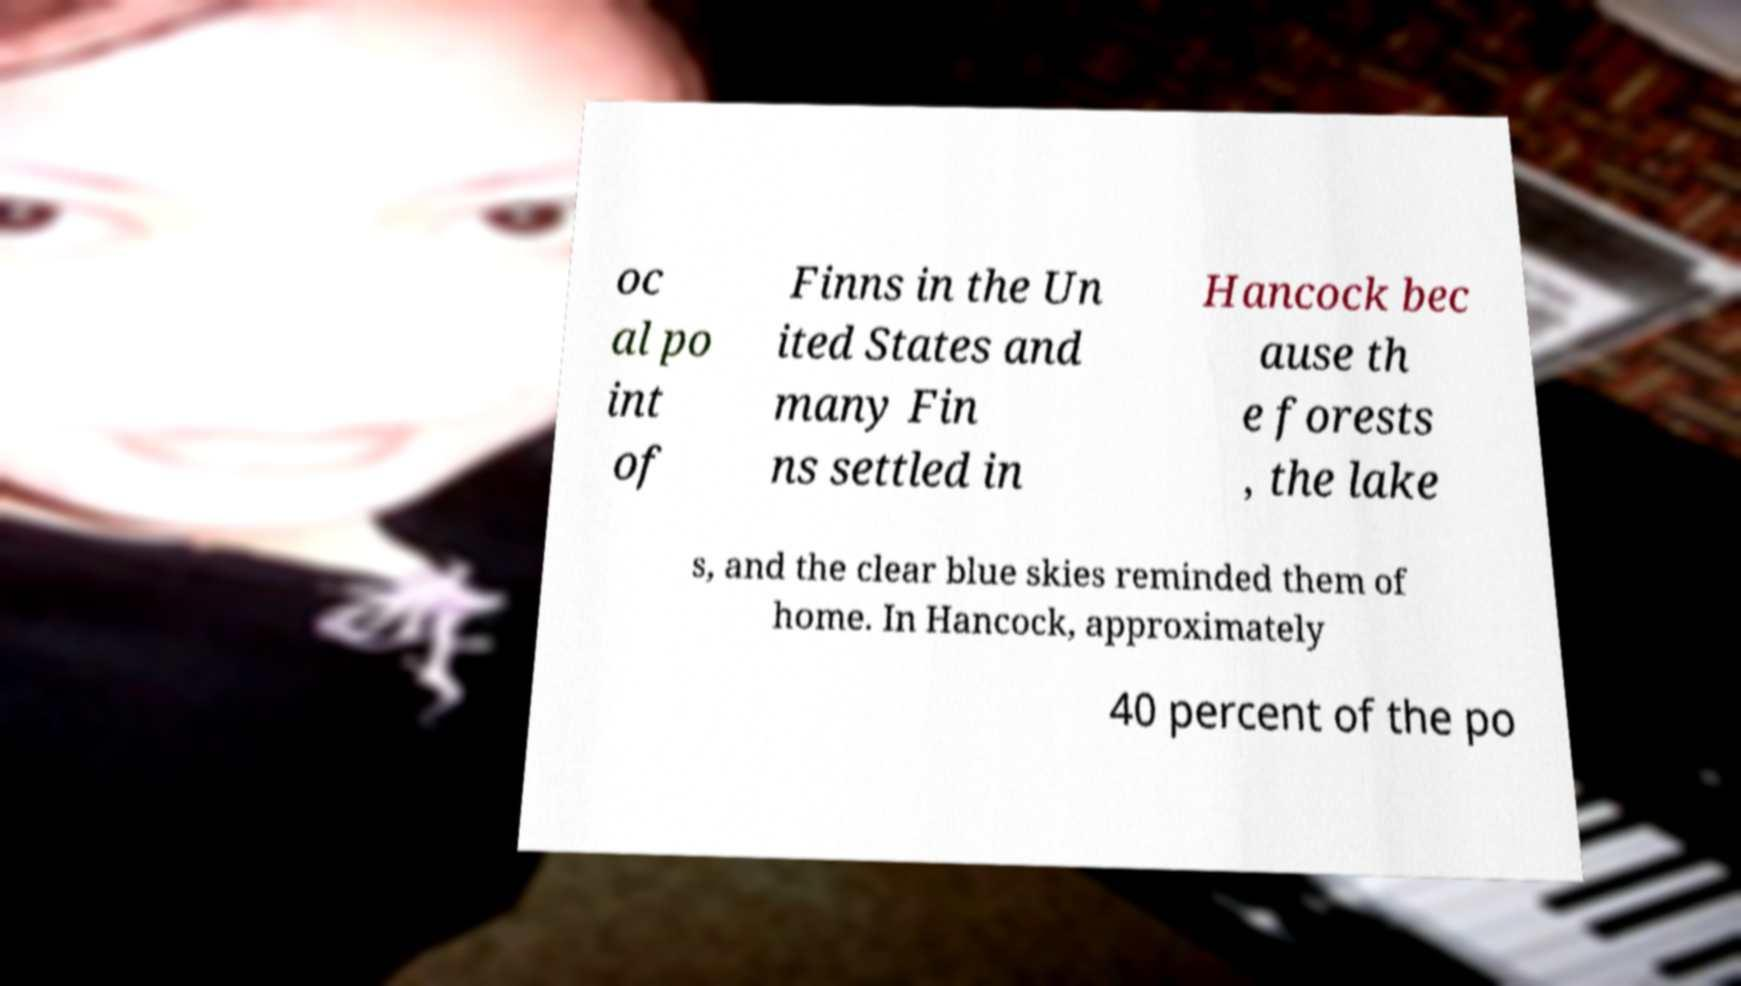Please identify and transcribe the text found in this image. oc al po int of Finns in the Un ited States and many Fin ns settled in Hancock bec ause th e forests , the lake s, and the clear blue skies reminded them of home. In Hancock, approximately 40 percent of the po 